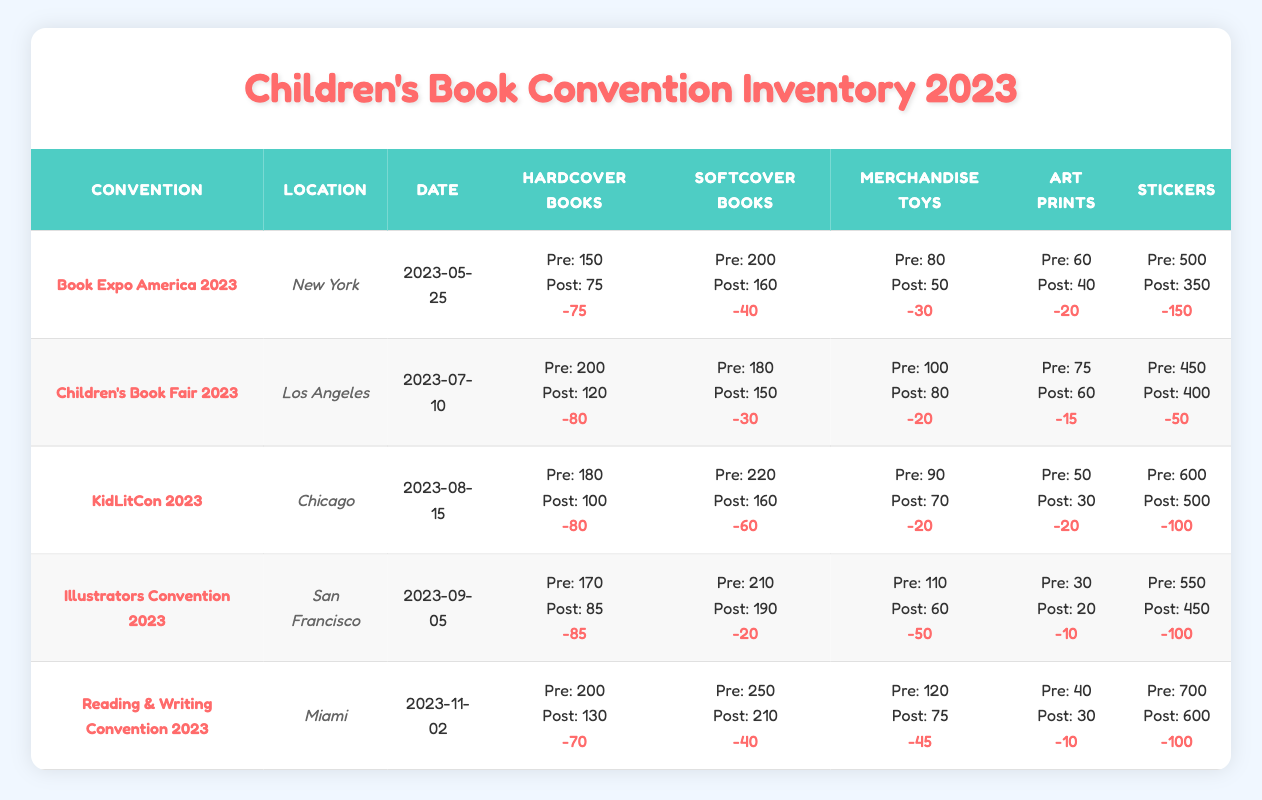What was the pre-convention inventory of hardcover books at the Children's Book Fair 2023? The table lists the pre-convention inventory for the Children's Book Fair 2023 under the heading "Hardcover Books," which indicates that it was 200.
Answer: 200 How many stickers were sold during the Book Expo America 2023? The pre-convention inventory of stickers was 500, and the post-convention inventory was 350. Thus, the number sold is 500 - 350 = 150.
Answer: 150 Which convention had the highest number of merchandise toys available before it started? By checking the pre-convention inventory for all conventions, "Reading & Writing Convention 2023" had the highest number of merchandise toys at 120.
Answer: Reading & Writing Convention 2023 Was the post-convention inventory of softcover books greater than that of hardcover books at KidLitCon 2023? The post-convention inventory for softcover books was 160, and for hardcover books, it was 100. Since 160 is greater than 100, the statement is true.
Answer: Yes What was the total decrease in the number of hardcover books after all conventions? The decreases for each convention are: 75 (Book Expo), 80 (Children's Book Fair), 80 (KidLitCon), 85 (Illustrators Convention), and 70 (Reading & Writing). Adding these gives 75 + 80 + 80 + 85 + 70 = 390.
Answer: 390 Which location hosted the convention with the largest loss of stickers inventory? By examining the decreases in stickers across all conventions, KidLitCon 2023 had a decrease of 100 stickers, which is the highest among the conventions.
Answer: KidLitCon 2023 How many more softcover books were available post-convention compared to merchandise toys at the Illustrators Convention 2023? Post-convention, there were 190 softcover books and 60 merchandise toys. The difference is 190 - 60 = 130, meaning there were 130 more softcover books available.
Answer: 130 What was the average pre-convention inventory of art prints across all five conventions? The pre-convention inventories for art prints were 60, 75, 50, 30, and 40. The total is 60 + 75 + 50 + 30 + 40 = 255. Dividing by 5 gives an average of 255 / 5 = 51.
Answer: 51 Did the pre-convention inventory of merchandise toys decrease after the KidLitCon 2023? The pre-convention inventory was 90, and the post-convention inventory was 70, indicating a decrease.
Answer: Yes What is the total difference in stickers available from pre to post-convention for all events? The changes in stickers were -150 (Book Expo), -50 (Children's Book Fair), -100 (KidLitCon), -100 (Illustrators Convention), and -100 (Reading & Writing). Summing this yields -500, so the total difference is 500 stickers.
Answer: 500 